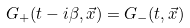<formula> <loc_0><loc_0><loc_500><loc_500>G _ { + } ( t - i \beta , \vec { x } ) = G _ { - } ( t , \vec { x } )</formula> 